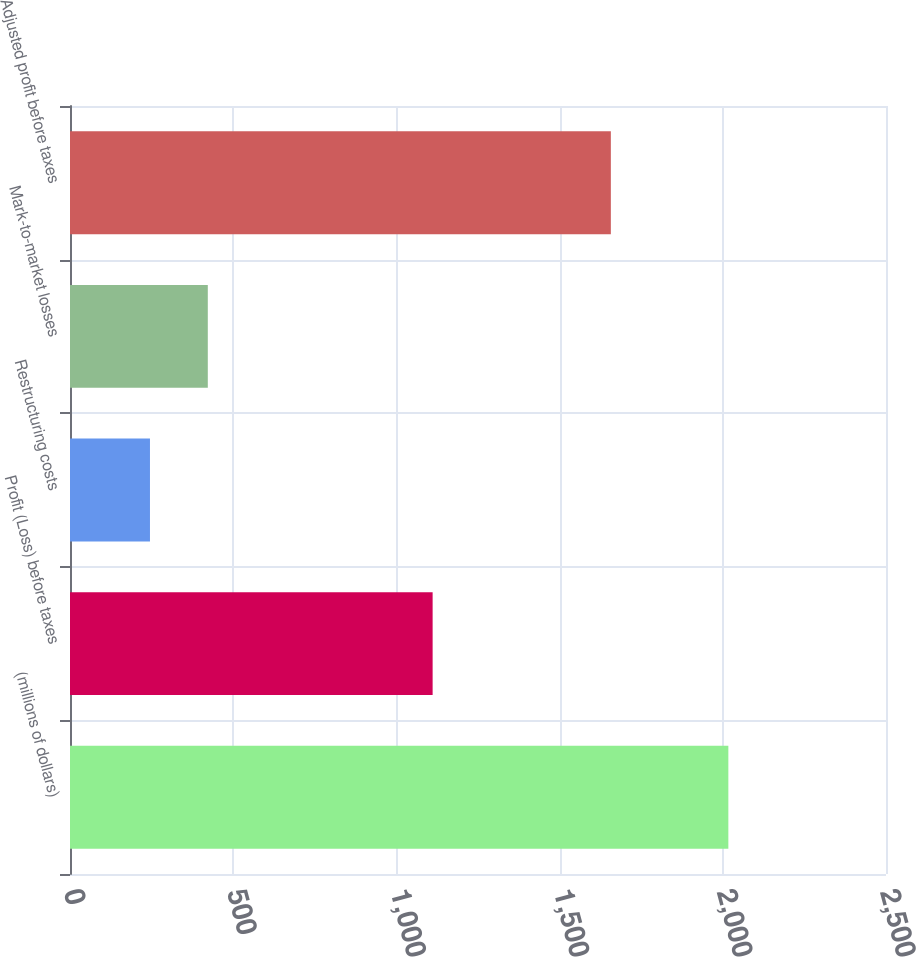Convert chart. <chart><loc_0><loc_0><loc_500><loc_500><bar_chart><fcel>(millions of dollars)<fcel>Profit (Loss) before taxes<fcel>Restructuring costs<fcel>Mark-to-market losses<fcel>Adjusted profit before taxes<nl><fcel>2017<fcel>1111<fcel>245<fcel>422.2<fcel>1657<nl></chart> 